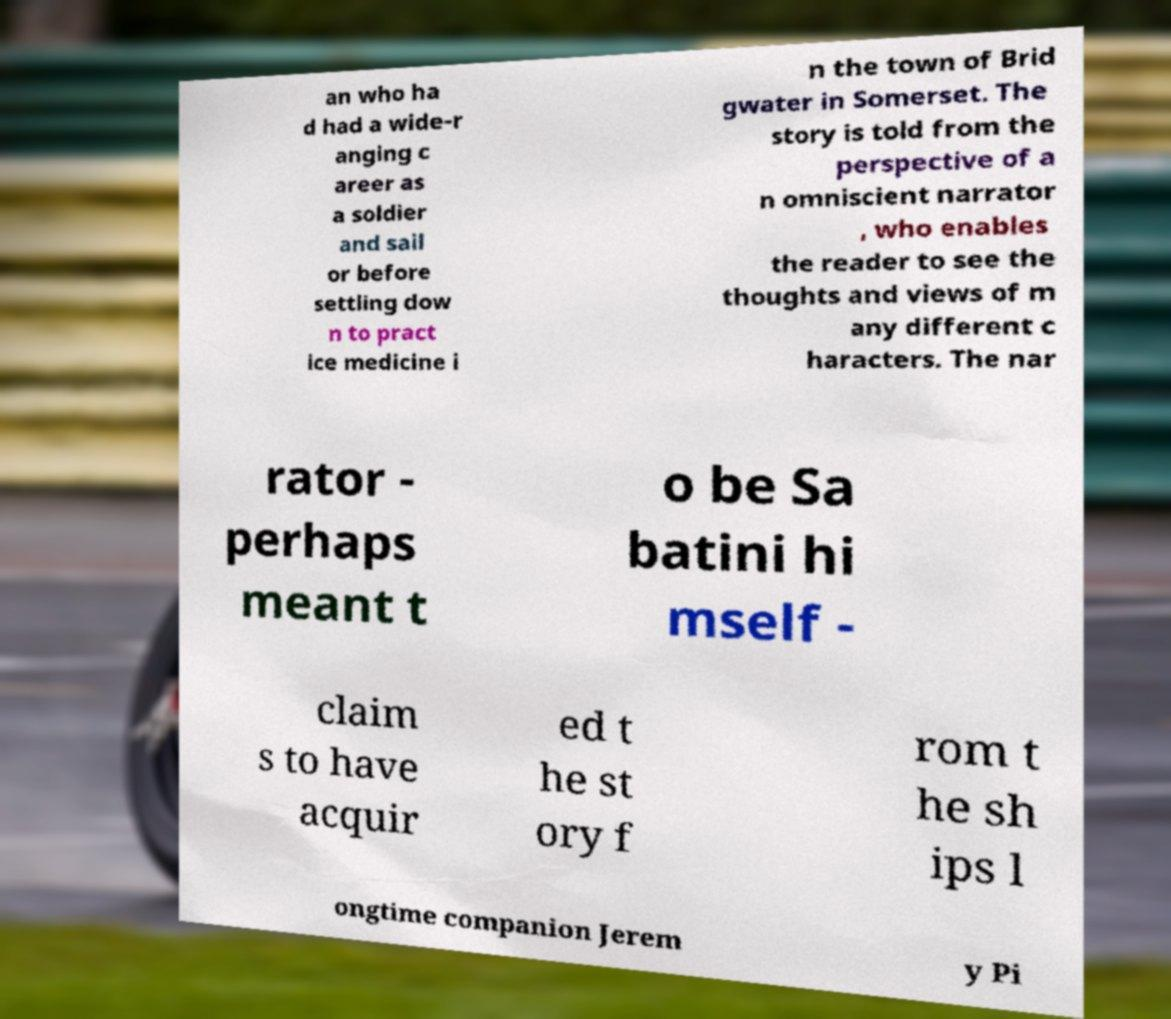Could you assist in decoding the text presented in this image and type it out clearly? an who ha d had a wide-r anging c areer as a soldier and sail or before settling dow n to pract ice medicine i n the town of Brid gwater in Somerset. The story is told from the perspective of a n omniscient narrator , who enables the reader to see the thoughts and views of m any different c haracters. The nar rator - perhaps meant t o be Sa batini hi mself - claim s to have acquir ed t he st ory f rom t he sh ips l ongtime companion Jerem y Pi 